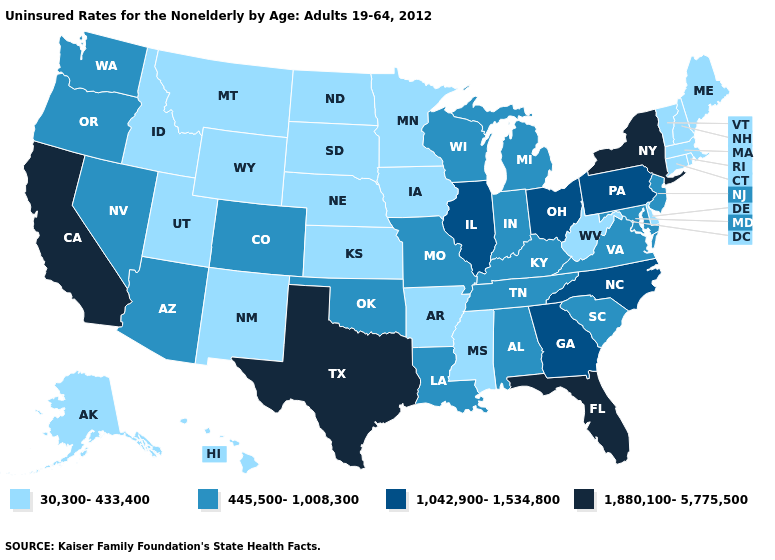What is the lowest value in states that border Virginia?
Answer briefly. 30,300-433,400. How many symbols are there in the legend?
Write a very short answer. 4. Name the states that have a value in the range 30,300-433,400?
Give a very brief answer. Alaska, Arkansas, Connecticut, Delaware, Hawaii, Idaho, Iowa, Kansas, Maine, Massachusetts, Minnesota, Mississippi, Montana, Nebraska, New Hampshire, New Mexico, North Dakota, Rhode Island, South Dakota, Utah, Vermont, West Virginia, Wyoming. Does Iowa have the highest value in the MidWest?
Keep it brief. No. Name the states that have a value in the range 1,880,100-5,775,500?
Concise answer only. California, Florida, New York, Texas. Does Indiana have the same value as Georgia?
Concise answer only. No. Name the states that have a value in the range 30,300-433,400?
Give a very brief answer. Alaska, Arkansas, Connecticut, Delaware, Hawaii, Idaho, Iowa, Kansas, Maine, Massachusetts, Minnesota, Mississippi, Montana, Nebraska, New Hampshire, New Mexico, North Dakota, Rhode Island, South Dakota, Utah, Vermont, West Virginia, Wyoming. Name the states that have a value in the range 1,880,100-5,775,500?
Keep it brief. California, Florida, New York, Texas. What is the highest value in the USA?
Short answer required. 1,880,100-5,775,500. Name the states that have a value in the range 445,500-1,008,300?
Write a very short answer. Alabama, Arizona, Colorado, Indiana, Kentucky, Louisiana, Maryland, Michigan, Missouri, Nevada, New Jersey, Oklahoma, Oregon, South Carolina, Tennessee, Virginia, Washington, Wisconsin. Does South Carolina have the lowest value in the South?
Keep it brief. No. Name the states that have a value in the range 1,042,900-1,534,800?
Be succinct. Georgia, Illinois, North Carolina, Ohio, Pennsylvania. What is the value of Kentucky?
Be succinct. 445,500-1,008,300. Name the states that have a value in the range 1,042,900-1,534,800?
Answer briefly. Georgia, Illinois, North Carolina, Ohio, Pennsylvania. Does the map have missing data?
Give a very brief answer. No. 